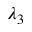Convert formula to latex. <formula><loc_0><loc_0><loc_500><loc_500>\lambda _ { 3 }</formula> 